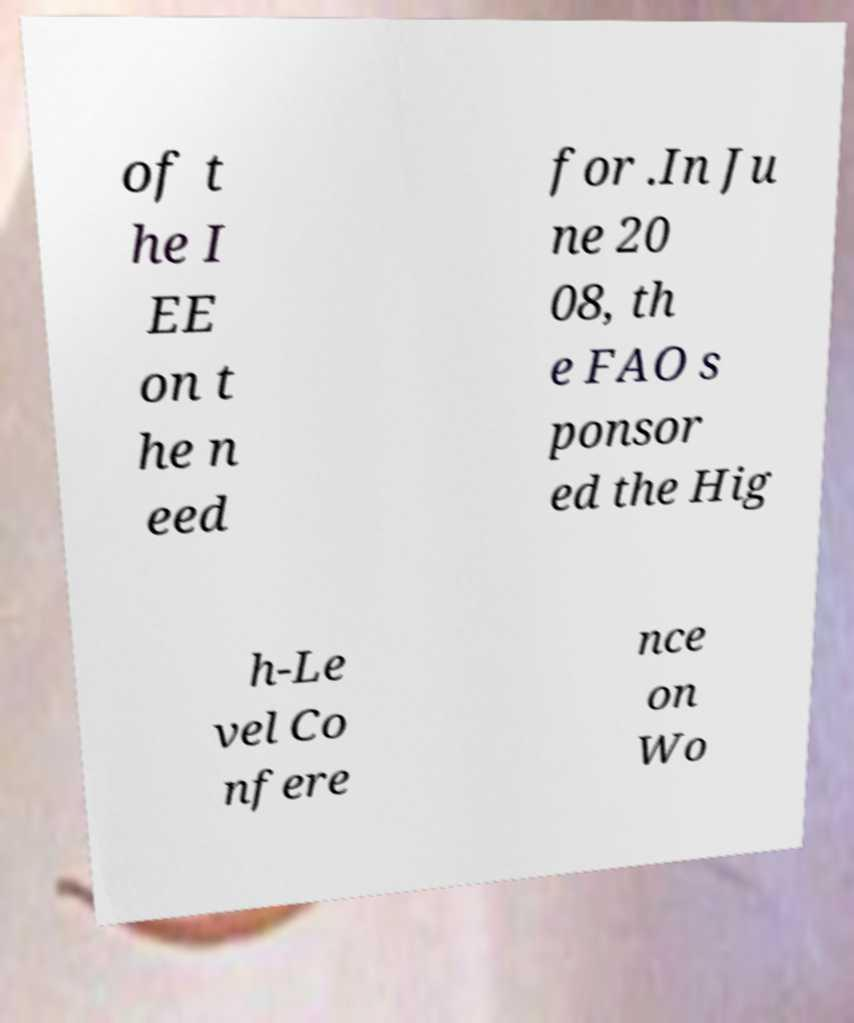For documentation purposes, I need the text within this image transcribed. Could you provide that? of t he I EE on t he n eed for .In Ju ne 20 08, th e FAO s ponsor ed the Hig h-Le vel Co nfere nce on Wo 